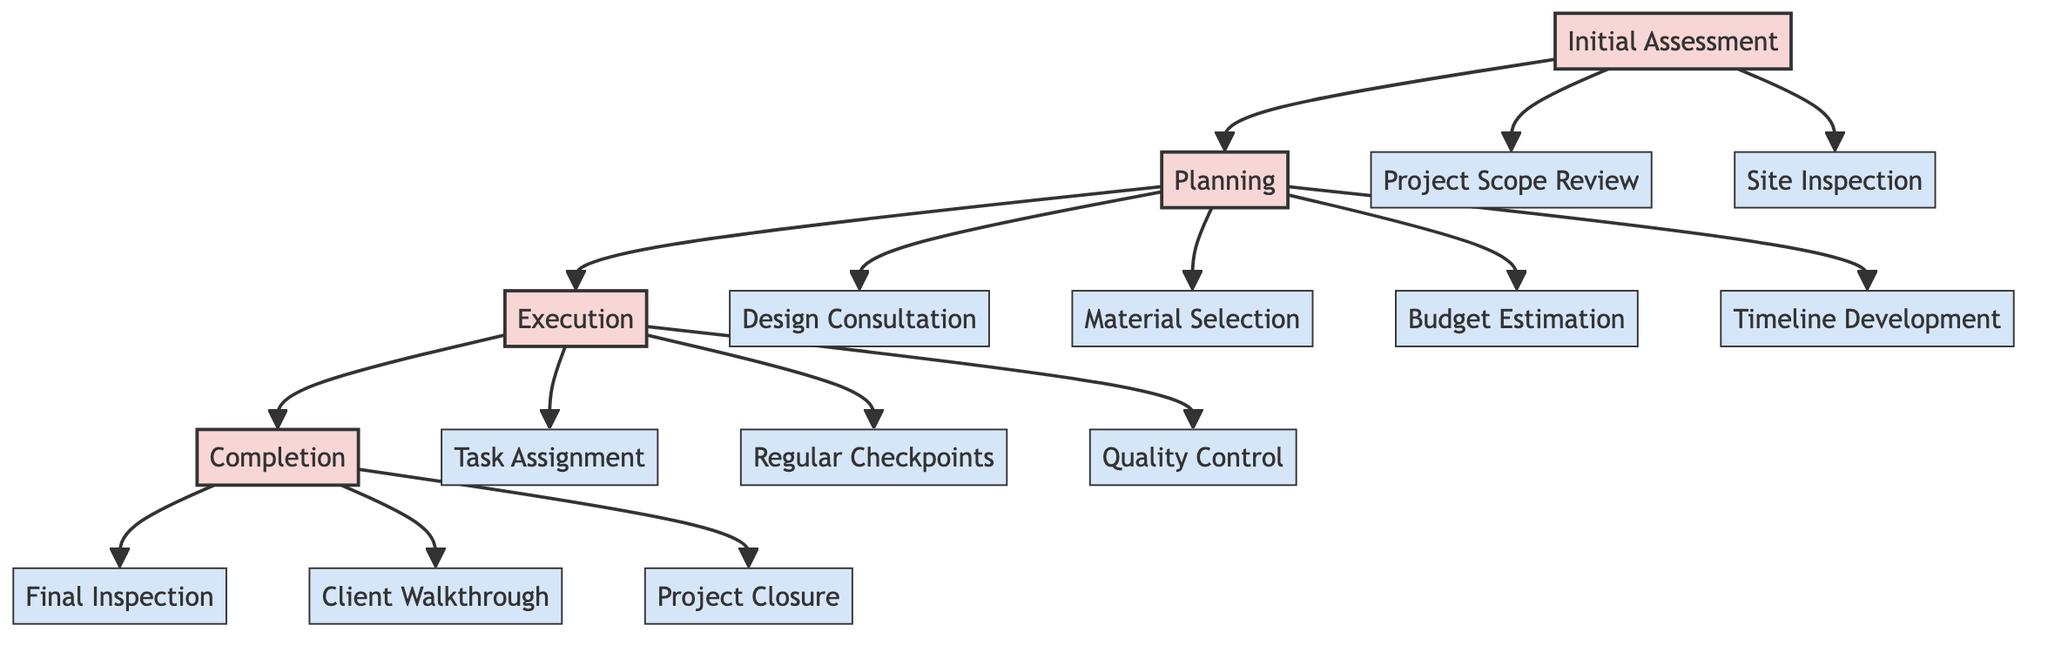What are the phases of the clinical pathway? The diagram presents four phases labeled as Initial Assessment, Planning, Execution, and Completion. Each phase consists of multiple steps that detail the process of project management in home renovation.
Answer: Initial Assessment, Planning, Execution, Completion How many steps are there in the Planning phase? The Planning phase includes four specific steps: Design Consultation, Material Selection, Budget Estimation, and Timeline Development. By counting these steps in the Planning section, we can determine the total.
Answer: 4 Which step involves the client and contractor? The steps that involve both the client and contractor are Project Scope Review in the Initial Assessment phase, Timeline Development in the Planning phase, Final Inspection, Client Walkthrough, and Project Closure in the Completion phase. These steps require active participation from both parties.
Answer: Project Scope Review, Timeline Development, Final Inspection, Client Walkthrough, Project Closure What tools are used during the Site Inspection? The Site Inspection step utilizes an Inspection Checklist and Measurement Tools. These tools help the contractor evaluate current conditions on-site effectively. By checking the diagram, you can identify the associated tools for each step.
Answer: Inspection Checklist, Measurement Tools Which phase comes before Execution? The flow of the diagram shows that the Planning phase directly precedes the Execution phase. This relationship indicates that all planning steps must be completed before execution begins.
Answer: Planning How many participants are involved in the task assignment? The Task Assignment step involves only the Contractor as a participant. This indicates that the contractor is responsible for assigning tasks to subcontractors, and no other role is included in this step.
Answer: Contractor What is the final step before project closure? The final step before project closure is the Client Walkthrough. This step allows the contractor and client to review the completed work and address any final concerns before closing the project. By examining the flow, we can identify this relationship.
Answer: Client Walkthrough What tools are used for Quality Control? For Quality Control, the tools specified are a Quality Assurance Checklist and Inspection Tools. These tools are essential for ensuring that the renovation work meets the required standards at key stages throughout the project.
Answer: Quality Assurance Checklist, Inspection Tools Which step includes design specialists? The Design Consultation step includes the involvement of design specialists alongside the contractor. This is critical for finalizing project details and ensuring that all design aspects meet client expectations.
Answer: Design Consultation 